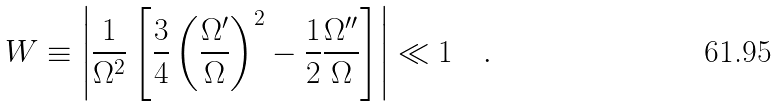Convert formula to latex. <formula><loc_0><loc_0><loc_500><loc_500>W \equiv \left | \frac { 1 } { \Omega ^ { 2 } } \left [ \frac { 3 } { 4 } \left ( \frac { \Omega ^ { \prime } } { \Omega } \right ) ^ { 2 } - \frac { 1 } { 2 } \frac { \Omega ^ { \prime \prime } } { \Omega } \right ] \right | \ll 1 \quad .</formula> 